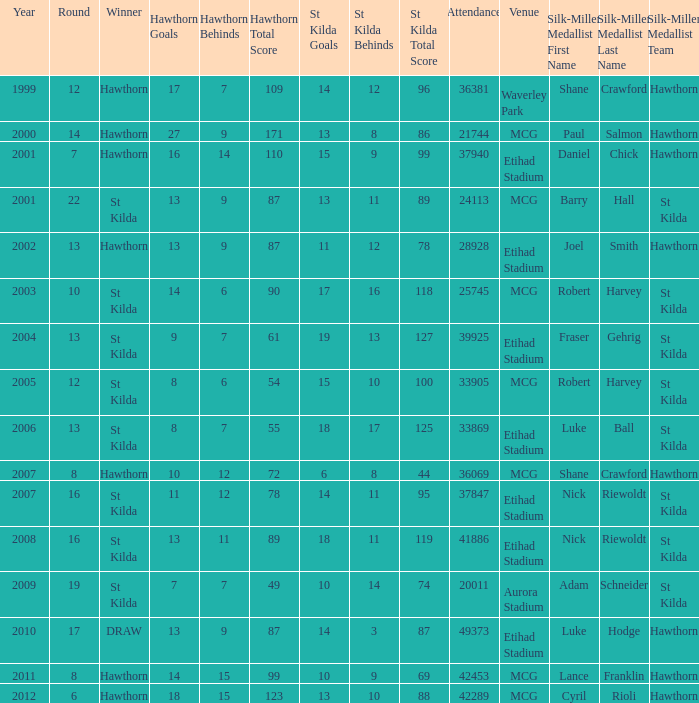What is the hawthorn score at the year 2000? 279171.0. 